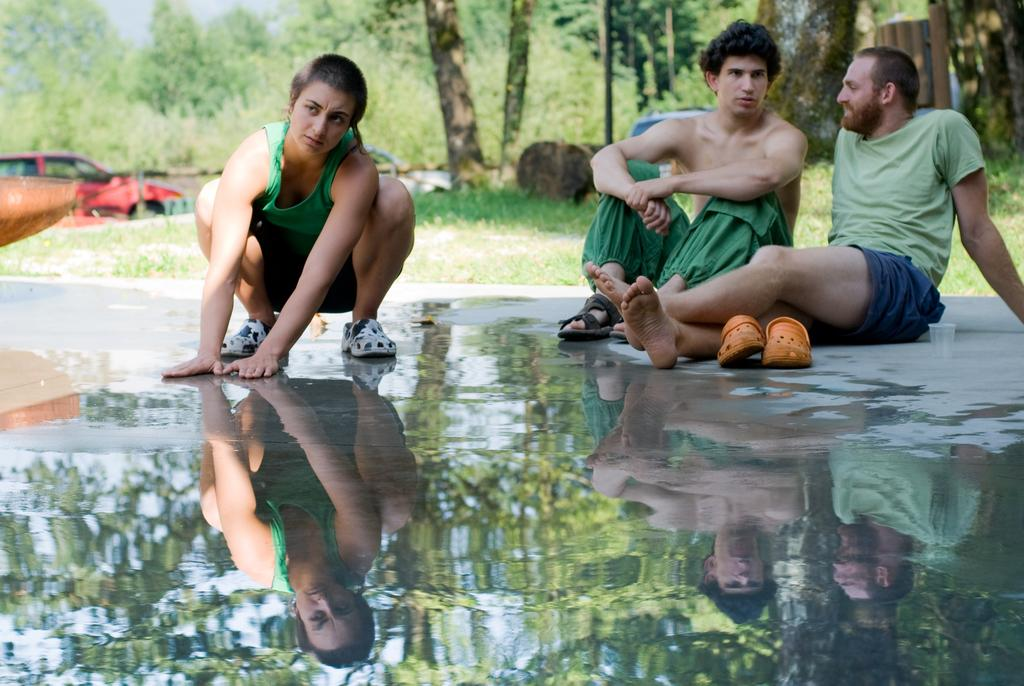How many people are in the image? There are three persons in the center of the image. What is the condition of the road in the image? There is water on the road at the bottom of the image. What can be seen in the background of the image? There are trees in the background of the image. Is there any vehicle present in the image? Yes, there is a car in the image. What type of bone can be seen in the image? There is no bone present in the image. How many stalks of celery are visible in the image? There is no celery present in the image. 